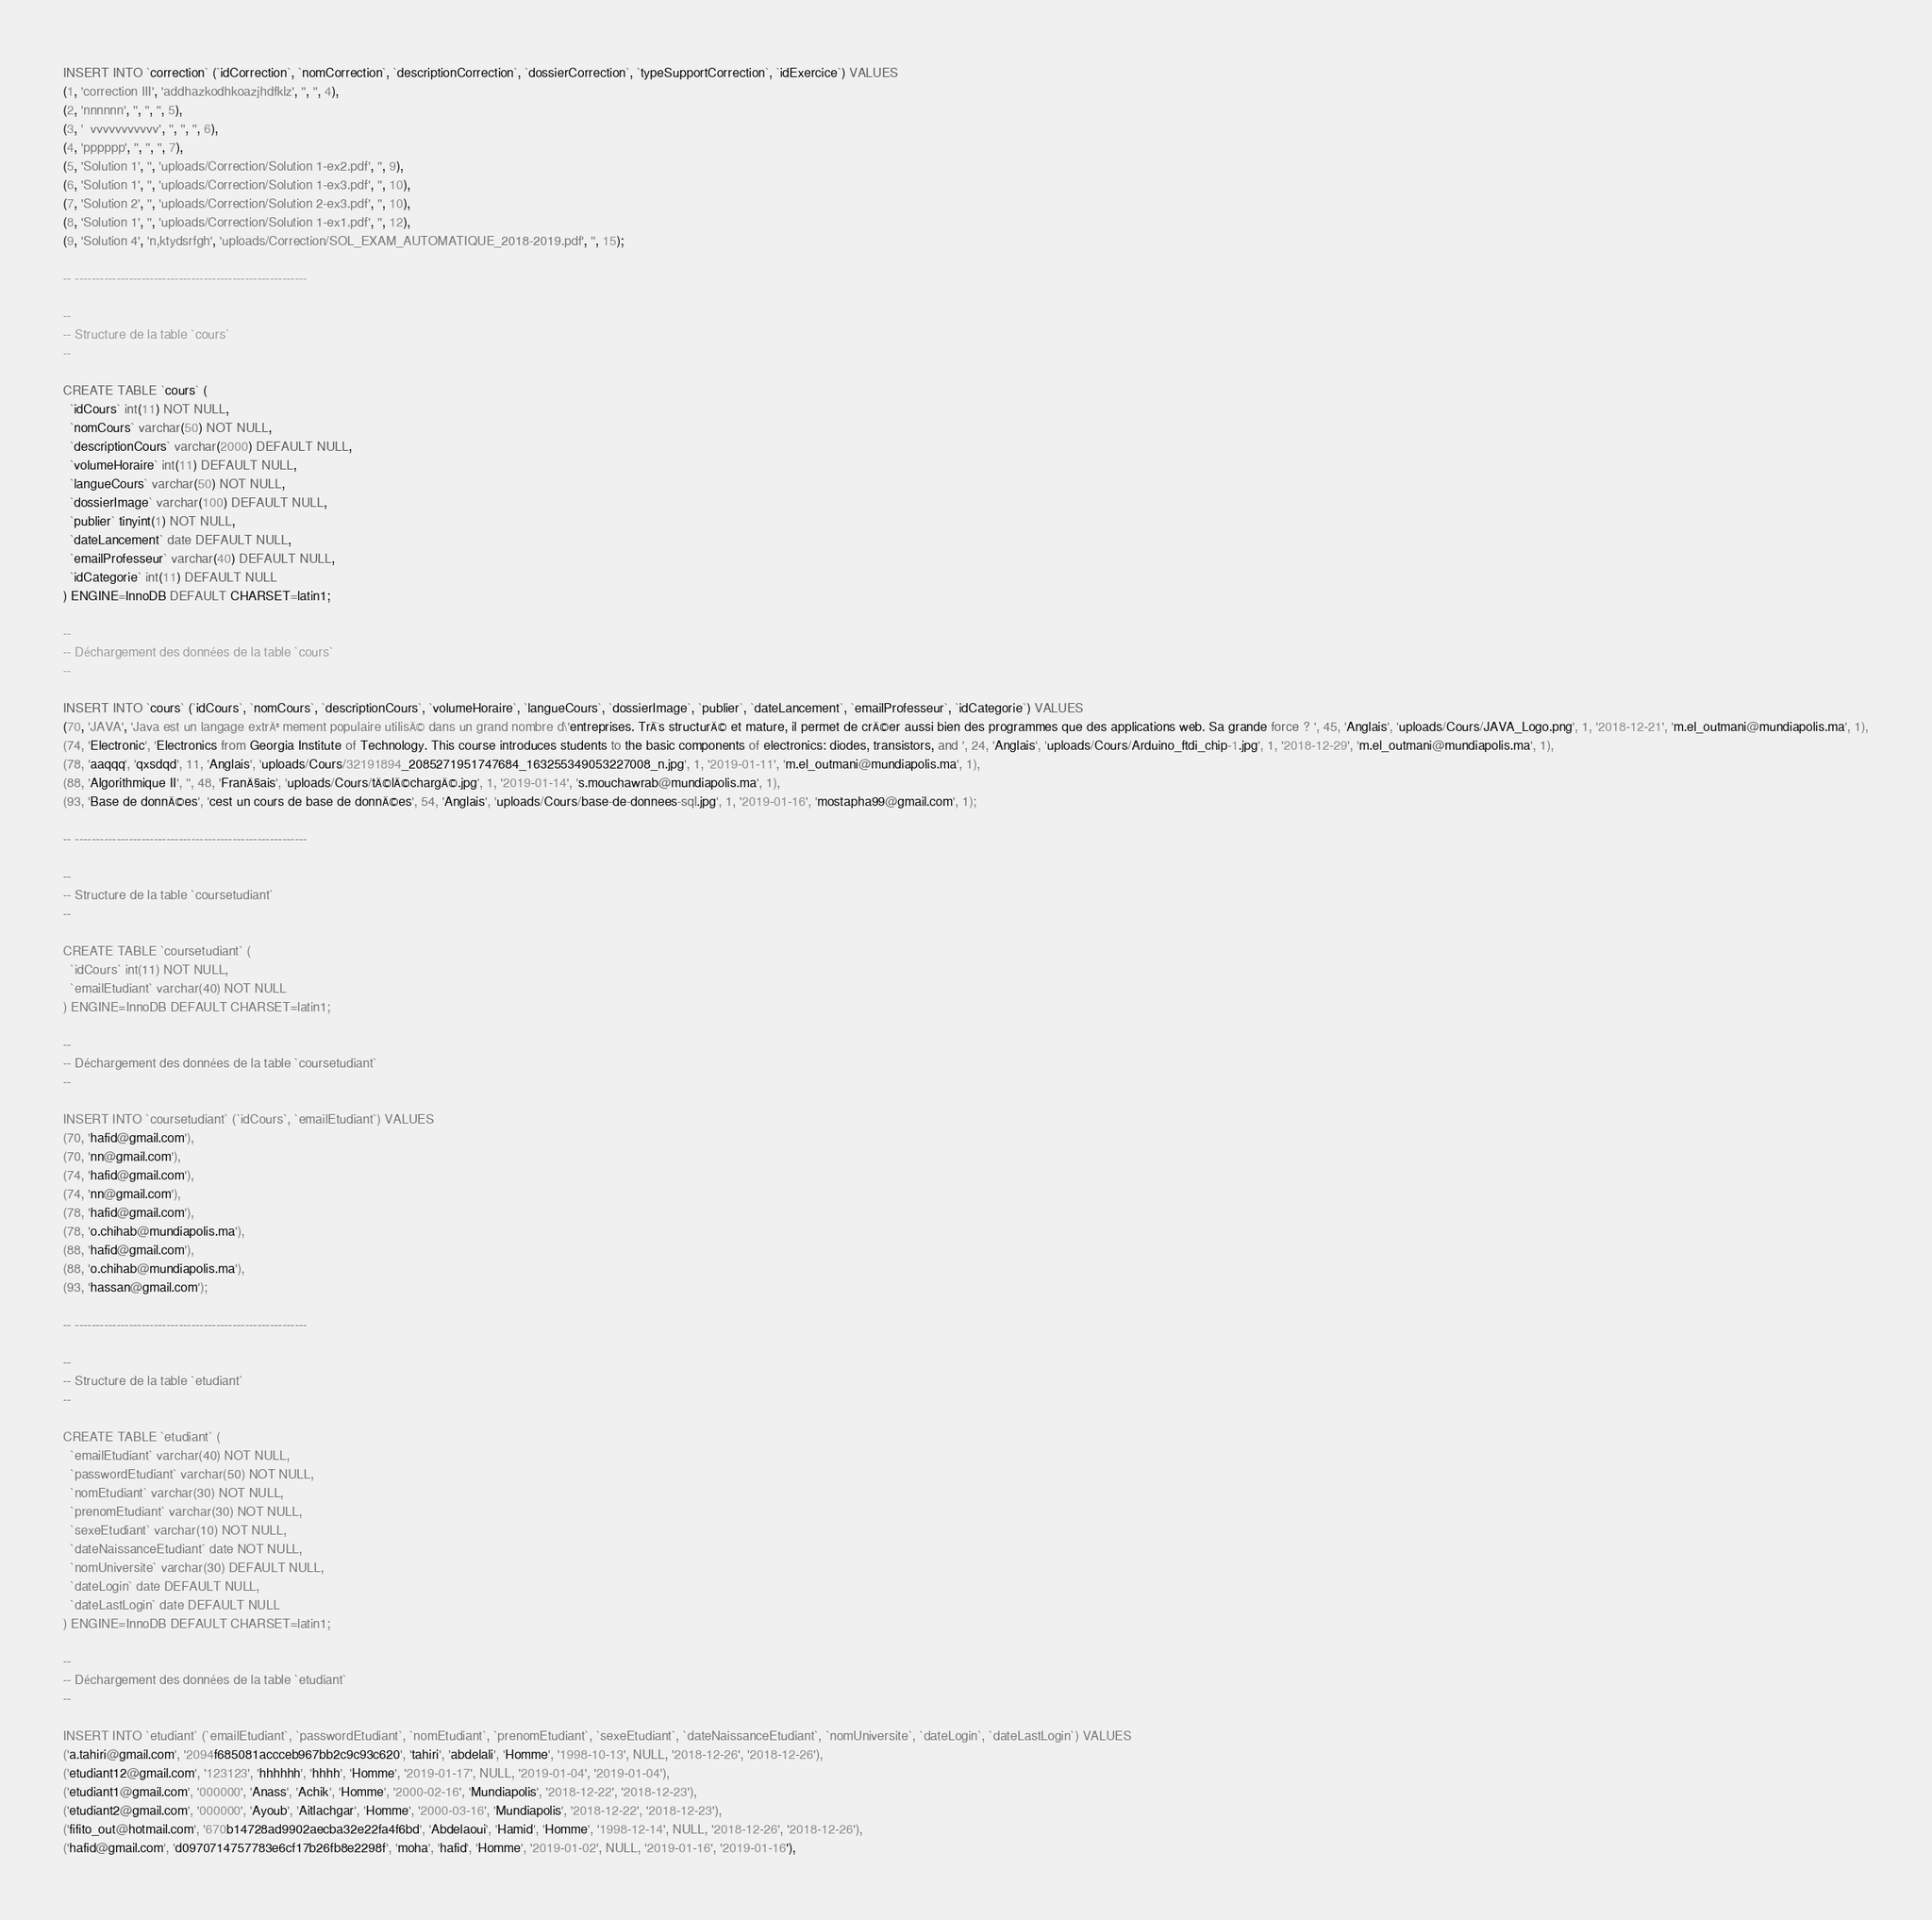<code> <loc_0><loc_0><loc_500><loc_500><_SQL_>INSERT INTO `correction` (`idCorrection`, `nomCorrection`, `descriptionCorrection`, `dossierCorrection`, `typeSupportCorrection`, `idExercice`) VALUES
(1, 'correction III', 'addhazkodhkoazjhdfklz', '', '', 4),
(2, 'nnnnnn', '', '', '', 5),
(3, '  vvvvvvvvvvv', '', '', '', 6),
(4, 'pppppp', '', '', '', 7),
(5, 'Solution 1', '', 'uploads/Correction/Solution 1-ex2.pdf', '', 9),
(6, 'Solution 1', '', 'uploads/Correction/Solution 1-ex3.pdf', '', 10),
(7, 'Solution 2', '', 'uploads/Correction/Solution 2-ex3.pdf', '', 10),
(8, 'Solution 1', '', 'uploads/Correction/Solution 1-ex1.pdf', '', 12),
(9, 'Solution 4', 'n,ktydsrfgh', 'uploads/Correction/SOL_EXAM_AUTOMATIQUE_2018-2019.pdf', '', 15);

-- --------------------------------------------------------

--
-- Structure de la table `cours`
--

CREATE TABLE `cours` (
  `idCours` int(11) NOT NULL,
  `nomCours` varchar(50) NOT NULL,
  `descriptionCours` varchar(2000) DEFAULT NULL,
  `volumeHoraire` int(11) DEFAULT NULL,
  `langueCours` varchar(50) NOT NULL,
  `dossierImage` varchar(100) DEFAULT NULL,
  `publier` tinyint(1) NOT NULL,
  `dateLancement` date DEFAULT NULL,
  `emailProfesseur` varchar(40) DEFAULT NULL,
  `idCategorie` int(11) DEFAULT NULL
) ENGINE=InnoDB DEFAULT CHARSET=latin1;

--
-- Déchargement des données de la table `cours`
--

INSERT INTO `cours` (`idCours`, `nomCours`, `descriptionCours`, `volumeHoraire`, `langueCours`, `dossierImage`, `publier`, `dateLancement`, `emailProfesseur`, `idCategorie`) VALUES
(70, 'JAVA', 'Java est un langage extrÃªmement populaire utilisÃ© dans un grand nombre d\'entreprises. TrÃ¨s structurÃ© et mature, il permet de crÃ©er aussi bien des programmes que des applications web. Sa grande force ? ', 45, 'Anglais', 'uploads/Cours/JAVA_Logo.png', 1, '2018-12-21', 'm.el_outmani@mundiapolis.ma', 1),
(74, 'Electronic', 'Electronics from Georgia Institute of Technology. This course introduces students to the basic components of electronics: diodes, transistors, and ', 24, 'Anglais', 'uploads/Cours/Arduino_ftdi_chip-1.jpg', 1, '2018-12-29', 'm.el_outmani@mundiapolis.ma', 1),
(78, 'aaqqq', 'qxsdqd', 11, 'Anglais', 'uploads/Cours/32191894_2085271951747684_163255349053227008_n.jpg', 1, '2019-01-11', 'm.el_outmani@mundiapolis.ma', 1),
(88, 'Algorithmique II', '', 48, 'FranÃ§ais', 'uploads/Cours/tÃ©lÃ©chargÃ©.jpg', 1, '2019-01-14', 's.mouchawrab@mundiapolis.ma', 1),
(93, 'Base de donnÃ©es', 'cest un cours de base de donnÃ©es', 54, 'Anglais', 'uploads/Cours/base-de-donnees-sql.jpg', 1, '2019-01-16', 'mostapha99@gmail.com', 1);

-- --------------------------------------------------------

--
-- Structure de la table `coursetudiant`
--

CREATE TABLE `coursetudiant` (
  `idCours` int(11) NOT NULL,
  `emailEtudiant` varchar(40) NOT NULL
) ENGINE=InnoDB DEFAULT CHARSET=latin1;

--
-- Déchargement des données de la table `coursetudiant`
--

INSERT INTO `coursetudiant` (`idCours`, `emailEtudiant`) VALUES
(70, 'hafid@gmail.com'),
(70, 'nn@gmail.com'),
(74, 'hafid@gmail.com'),
(74, 'nn@gmail.com'),
(78, 'hafid@gmail.com'),
(78, 'o.chihab@mundiapolis.ma'),
(88, 'hafid@gmail.com'),
(88, 'o.chihab@mundiapolis.ma'),
(93, 'hassan@gmail.com');

-- --------------------------------------------------------

--
-- Structure de la table `etudiant`
--

CREATE TABLE `etudiant` (
  `emailEtudiant` varchar(40) NOT NULL,
  `passwordEtudiant` varchar(50) NOT NULL,
  `nomEtudiant` varchar(30) NOT NULL,
  `prenomEtudiant` varchar(30) NOT NULL,
  `sexeEtudiant` varchar(10) NOT NULL,
  `dateNaissanceEtudiant` date NOT NULL,
  `nomUniversite` varchar(30) DEFAULT NULL,
  `dateLogin` date DEFAULT NULL,
  `dateLastLogin` date DEFAULT NULL
) ENGINE=InnoDB DEFAULT CHARSET=latin1;

--
-- Déchargement des données de la table `etudiant`
--

INSERT INTO `etudiant` (`emailEtudiant`, `passwordEtudiant`, `nomEtudiant`, `prenomEtudiant`, `sexeEtudiant`, `dateNaissanceEtudiant`, `nomUniversite`, `dateLogin`, `dateLastLogin`) VALUES
('a.tahiri@gmail.com', '2094f685081accceb967bb2c9c93c620', 'tahiri', 'abdelali', 'Homme', '1998-10-13', NULL, '2018-12-26', '2018-12-26'),
('etudiant12@gmail.com', '123123', 'hhhhhh', 'hhhh', 'Homme', '2019-01-17', NULL, '2019-01-04', '2019-01-04'),
('etudiant1@gmail.com', '000000', 'Anass', 'Achik', 'Homme', '2000-02-16', 'Mundiapolis', '2018-12-22', '2018-12-23'),
('etudiant2@gmail.com', '000000', 'Ayoub', 'Aitlachgar', 'Homme', '2000-03-16', 'Mundiapolis', '2018-12-22', '2018-12-23'),
('fifito_out@hotmail.com', '670b14728ad9902aecba32e22fa4f6bd', 'Abdelaoui', 'Hamid', 'Homme', '1998-12-14', NULL, '2018-12-26', '2018-12-26'),
('hafid@gmail.com', 'd0970714757783e6cf17b26fb8e2298f', 'moha', 'hafid', 'Homme', '2019-01-02', NULL, '2019-01-16', '2019-01-16'),</code> 